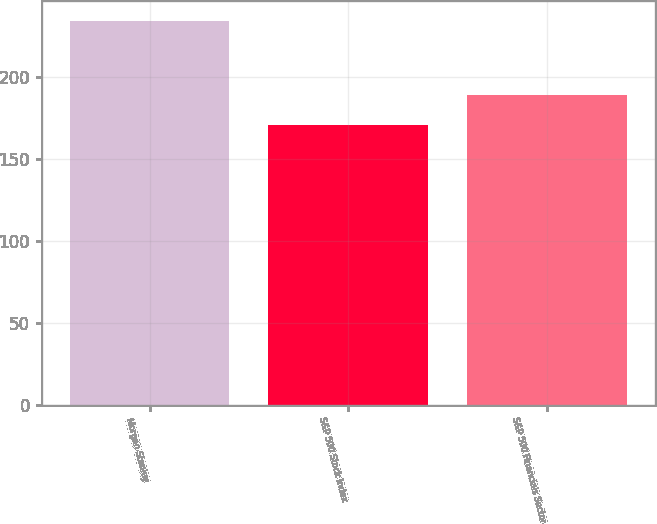Convert chart. <chart><loc_0><loc_0><loc_500><loc_500><bar_chart><fcel>Morgan Stanley<fcel>S&P 500 Stock Index<fcel>S&P 500 Financials Sector<nl><fcel>234.24<fcel>170.78<fcel>188.69<nl></chart> 